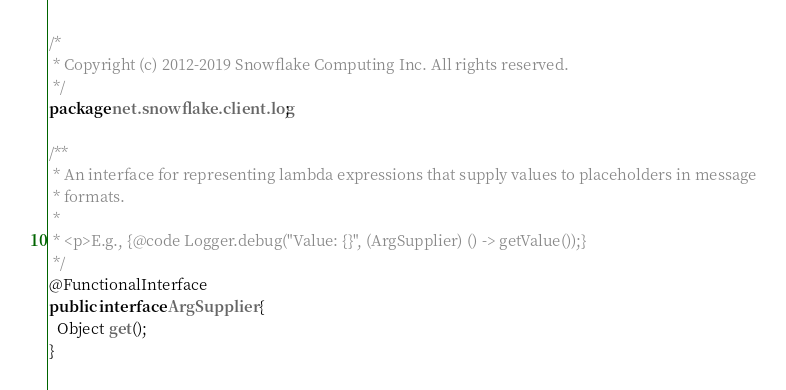Convert code to text. <code><loc_0><loc_0><loc_500><loc_500><_Java_>/*
 * Copyright (c) 2012-2019 Snowflake Computing Inc. All rights reserved.
 */
package net.snowflake.client.log;

/**
 * An interface for representing lambda expressions that supply values to placeholders in message
 * formats.
 *
 * <p>E.g., {@code Logger.debug("Value: {}", (ArgSupplier) () -> getValue());}
 */
@FunctionalInterface
public interface ArgSupplier {
  Object get();
}
</code> 